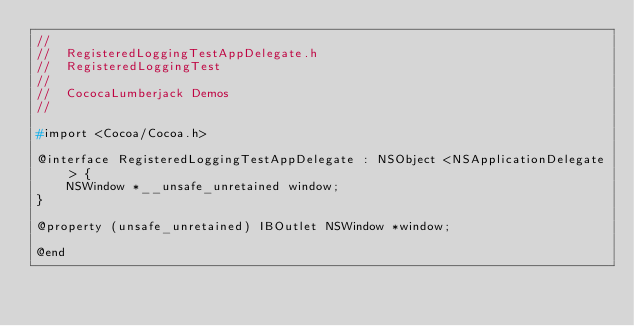Convert code to text. <code><loc_0><loc_0><loc_500><loc_500><_C_>//
//  RegisteredLoggingTestAppDelegate.h
//  RegisteredLoggingTest
//
//  CococaLumberjack Demos
//

#import <Cocoa/Cocoa.h>

@interface RegisteredLoggingTestAppDelegate : NSObject <NSApplicationDelegate> {
    NSWindow *__unsafe_unretained window;
}

@property (unsafe_unretained) IBOutlet NSWindow *window;

@end
</code> 